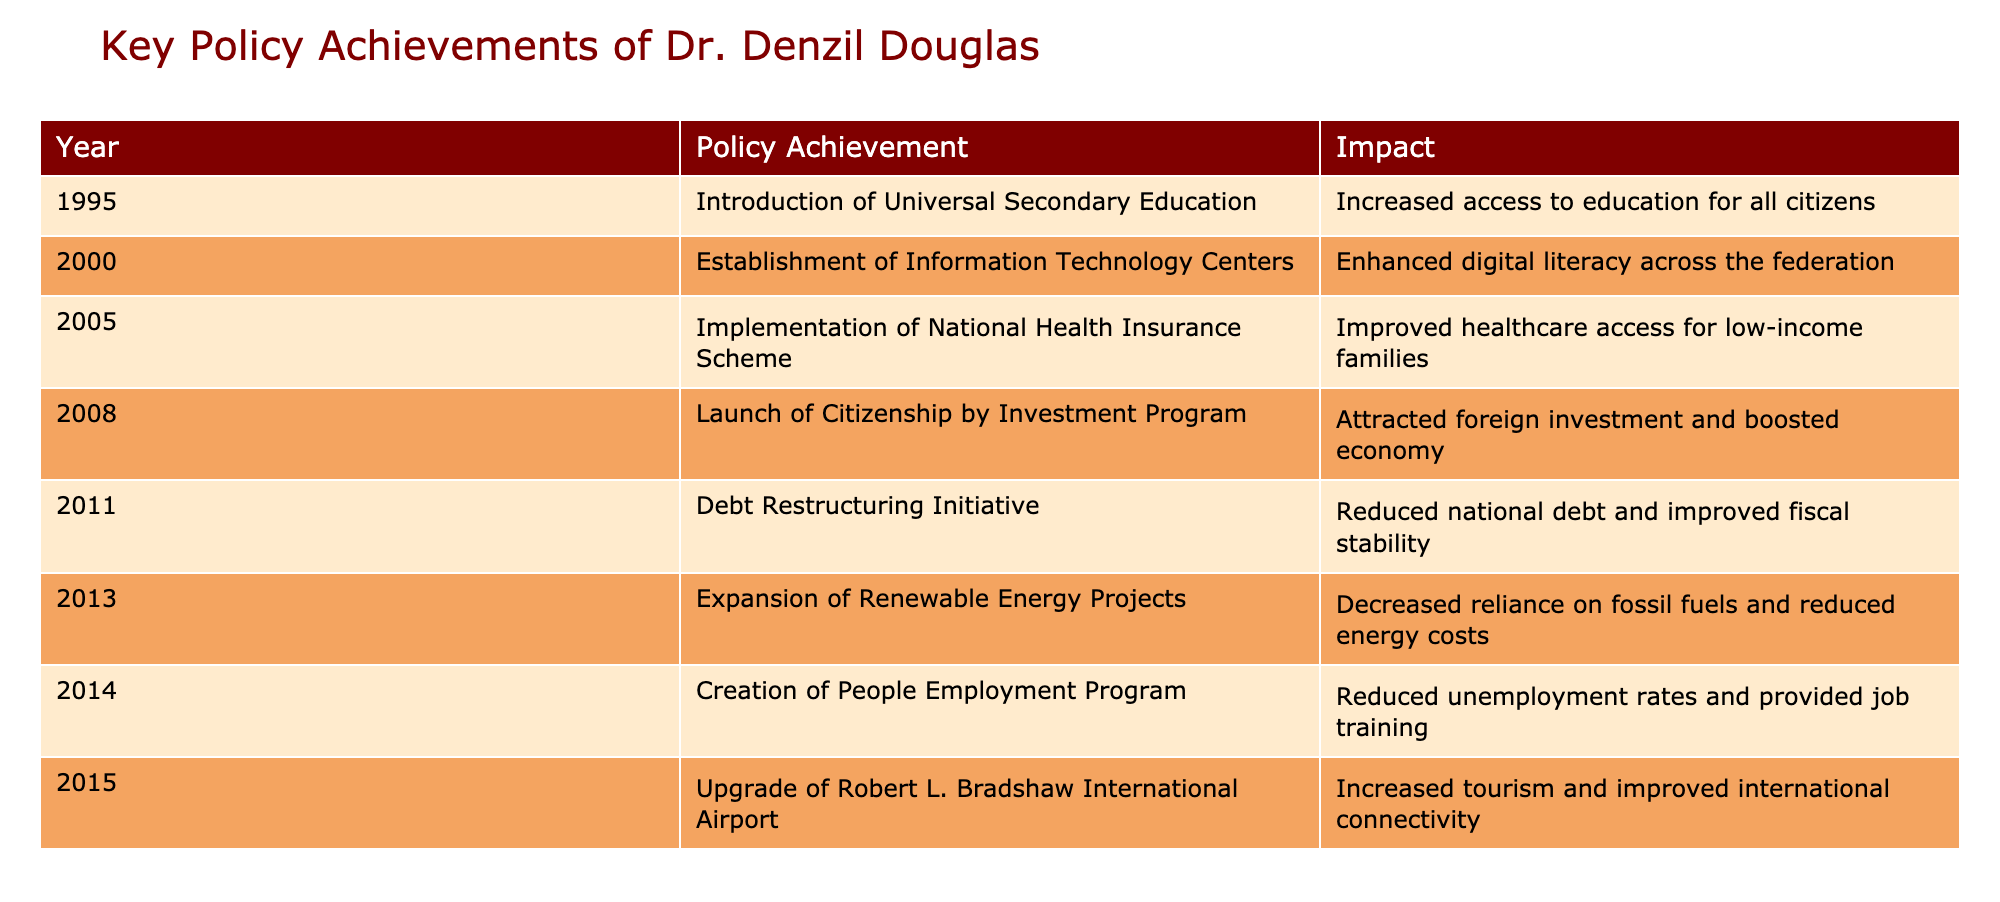What policy achievement was introduced in 2000? According to the table, in 2000, the policy achievement noted is the establishment of Information Technology Centers.
Answer: Establishment of Information Technology Centers Which year saw the launch of the Citizenship by Investment Program? The table indicates that the Citizenship by Investment Program was launched in 2008.
Answer: 2008 What impact did the implementation of the National Health Insurance Scheme have? The table states that the impact of the National Health Insurance Scheme was improved healthcare access for low-income families.
Answer: Improved healthcare access for low-income families How many policy achievements occurred between 1995 and 2010? To find the number of policy achievements from 1995 to 2010, we count the entries from that time frame in the table: there are six entries.
Answer: 6 Did the creation of the People Employment Program contribute to reducing unemployment rates? Yes, the table reports that the People Employment Program had the impact of reducing unemployment rates and providing job training.
Answer: Yes What is the difference between the years of the introduction of Universal Secondary Education and the launch of Renewable Energy Projects? Universal Secondary Education was introduced in 1995, and Renewable Energy Projects were expanded in 2013. The difference in years is 2013 - 1995 = 18 years.
Answer: 18 years Was the Upgrade of Robert L. Bradshaw International Airport achieved before or after the launch of the Citizenship by Investment Program? The table shows that the Upgrade of Robert L. Bradshaw International Airport happened in 2015, which is after the launch of the Citizenship by Investment Program in 2008.
Answer: After What was the total number of significant policy achievements listed in the table? The table contains a total of eight policy achievements, recognized from 1995 to 2015.
Answer: 8 In which policy achievement was the impact focused on reducing reliance on fossil fuels? The table states that the expansion of Renewable Energy Projects had the impact of decreasing reliance on fossil fuels.
Answer: Expansion of Renewable Energy Projects 